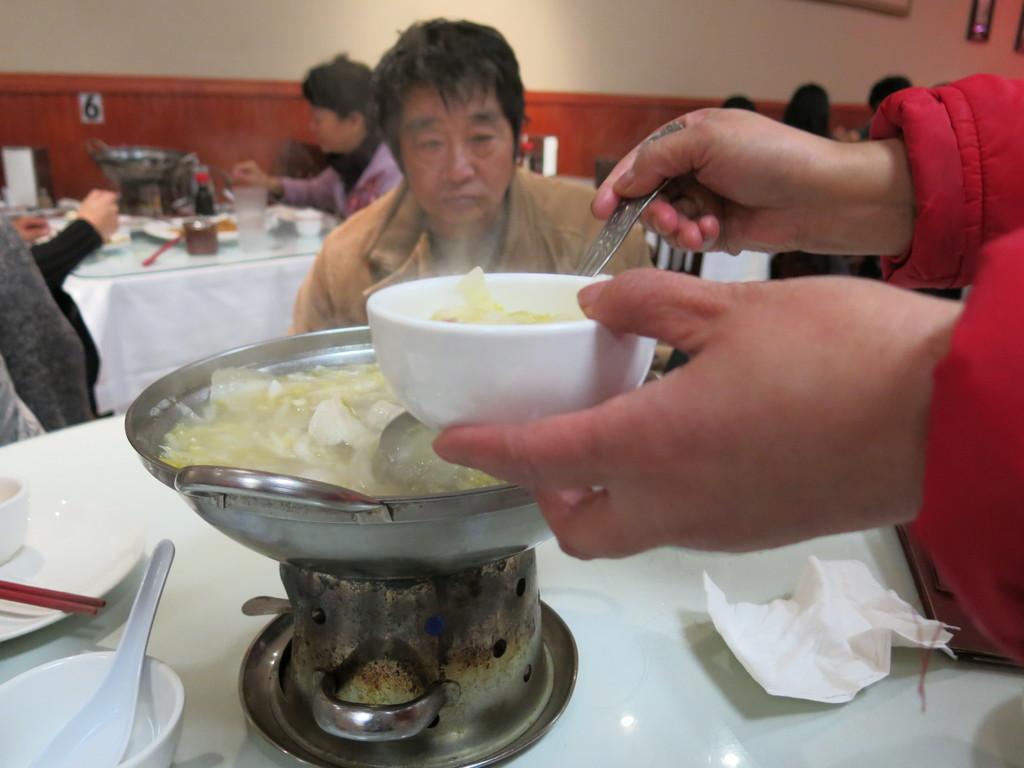Could you give a brief overview of what you see in this image? In this image we can see a group of persons are sitting on the chair, and in front here is the table, and here they are cooking, and some objects on it, and here is the wall. 